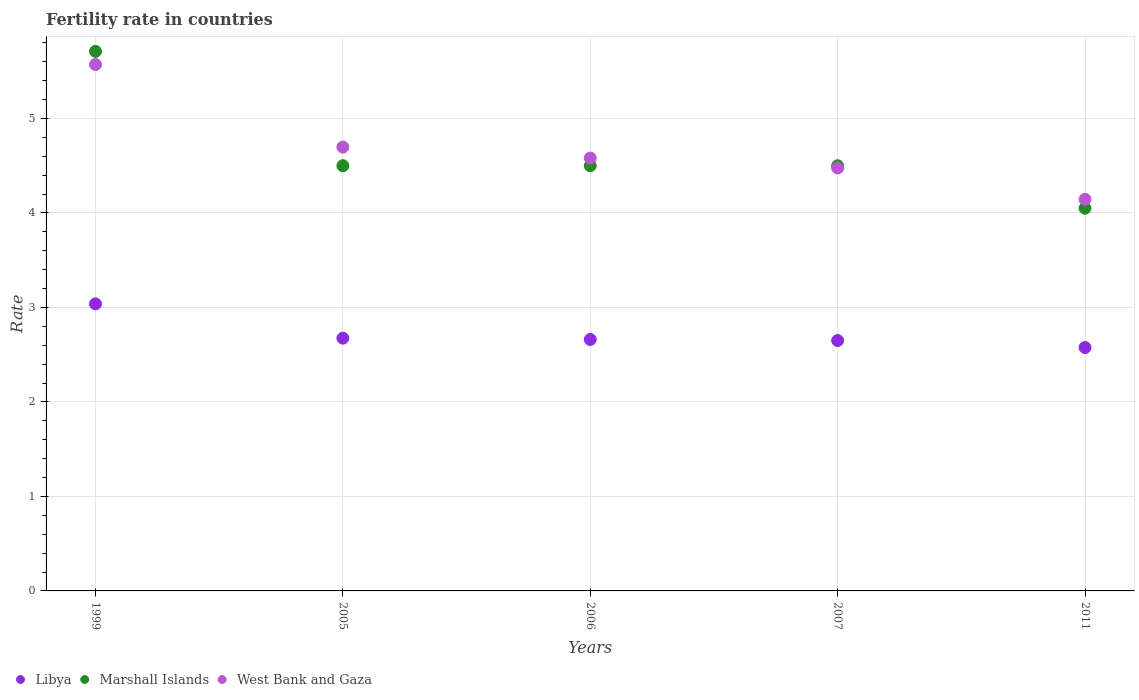Across all years, what is the maximum fertility rate in Libya?
Offer a very short reply. 3.04. Across all years, what is the minimum fertility rate in Marshall Islands?
Provide a succinct answer. 4.05. In which year was the fertility rate in Marshall Islands maximum?
Provide a short and direct response. 1999. In which year was the fertility rate in Marshall Islands minimum?
Provide a short and direct response. 2011. What is the total fertility rate in West Bank and Gaza in the graph?
Make the answer very short. 23.47. What is the difference between the fertility rate in Libya in 1999 and that in 2005?
Give a very brief answer. 0.36. What is the average fertility rate in Marshall Islands per year?
Provide a succinct answer. 4.65. In the year 2007, what is the difference between the fertility rate in Marshall Islands and fertility rate in Libya?
Your answer should be compact. 1.85. What is the ratio of the fertility rate in West Bank and Gaza in 1999 to that in 2005?
Offer a terse response. 1.19. Is the fertility rate in West Bank and Gaza in 1999 less than that in 2007?
Ensure brevity in your answer.  No. Is the difference between the fertility rate in Marshall Islands in 2005 and 2006 greater than the difference between the fertility rate in Libya in 2005 and 2006?
Keep it short and to the point. No. What is the difference between the highest and the second highest fertility rate in West Bank and Gaza?
Give a very brief answer. 0.87. What is the difference between the highest and the lowest fertility rate in West Bank and Gaza?
Your response must be concise. 1.43. Is the sum of the fertility rate in West Bank and Gaza in 1999 and 2006 greater than the maximum fertility rate in Marshall Islands across all years?
Your response must be concise. Yes. Is the fertility rate in Libya strictly less than the fertility rate in West Bank and Gaza over the years?
Your answer should be compact. Yes. How many dotlines are there?
Provide a succinct answer. 3. How many years are there in the graph?
Give a very brief answer. 5. What is the difference between two consecutive major ticks on the Y-axis?
Keep it short and to the point. 1. Does the graph contain any zero values?
Your response must be concise. No. How many legend labels are there?
Ensure brevity in your answer.  3. What is the title of the graph?
Make the answer very short. Fertility rate in countries. What is the label or title of the Y-axis?
Offer a terse response. Rate. What is the Rate in Libya in 1999?
Your answer should be very brief. 3.04. What is the Rate of Marshall Islands in 1999?
Your response must be concise. 5.71. What is the Rate in West Bank and Gaza in 1999?
Ensure brevity in your answer.  5.57. What is the Rate of Libya in 2005?
Ensure brevity in your answer.  2.67. What is the Rate in West Bank and Gaza in 2005?
Keep it short and to the point. 4.7. What is the Rate in Libya in 2006?
Ensure brevity in your answer.  2.66. What is the Rate in Marshall Islands in 2006?
Provide a succinct answer. 4.5. What is the Rate of West Bank and Gaza in 2006?
Keep it short and to the point. 4.58. What is the Rate in Libya in 2007?
Give a very brief answer. 2.65. What is the Rate in West Bank and Gaza in 2007?
Give a very brief answer. 4.48. What is the Rate in Libya in 2011?
Give a very brief answer. 2.58. What is the Rate in Marshall Islands in 2011?
Your answer should be very brief. 4.05. What is the Rate in West Bank and Gaza in 2011?
Give a very brief answer. 4.14. Across all years, what is the maximum Rate of Libya?
Provide a succinct answer. 3.04. Across all years, what is the maximum Rate of Marshall Islands?
Your response must be concise. 5.71. Across all years, what is the maximum Rate of West Bank and Gaza?
Your answer should be compact. 5.57. Across all years, what is the minimum Rate in Libya?
Your answer should be very brief. 2.58. Across all years, what is the minimum Rate of Marshall Islands?
Your answer should be compact. 4.05. Across all years, what is the minimum Rate of West Bank and Gaza?
Give a very brief answer. 4.14. What is the total Rate of Libya in the graph?
Offer a terse response. 13.6. What is the total Rate of Marshall Islands in the graph?
Your answer should be very brief. 23.26. What is the total Rate in West Bank and Gaza in the graph?
Offer a very short reply. 23.47. What is the difference between the Rate in Libya in 1999 and that in 2005?
Ensure brevity in your answer.  0.36. What is the difference between the Rate of Marshall Islands in 1999 and that in 2005?
Offer a very short reply. 1.21. What is the difference between the Rate in West Bank and Gaza in 1999 and that in 2005?
Make the answer very short. 0.87. What is the difference between the Rate in Libya in 1999 and that in 2006?
Make the answer very short. 0.38. What is the difference between the Rate in Marshall Islands in 1999 and that in 2006?
Your answer should be very brief. 1.21. What is the difference between the Rate of West Bank and Gaza in 1999 and that in 2006?
Offer a very short reply. 0.99. What is the difference between the Rate in Libya in 1999 and that in 2007?
Give a very brief answer. 0.39. What is the difference between the Rate in Marshall Islands in 1999 and that in 2007?
Make the answer very short. 1.21. What is the difference between the Rate of West Bank and Gaza in 1999 and that in 2007?
Your response must be concise. 1.09. What is the difference between the Rate of Libya in 1999 and that in 2011?
Your answer should be compact. 0.46. What is the difference between the Rate in Marshall Islands in 1999 and that in 2011?
Your response must be concise. 1.66. What is the difference between the Rate in West Bank and Gaza in 1999 and that in 2011?
Your answer should be compact. 1.43. What is the difference between the Rate of Libya in 2005 and that in 2006?
Give a very brief answer. 0.01. What is the difference between the Rate in Marshall Islands in 2005 and that in 2006?
Your answer should be very brief. 0. What is the difference between the Rate of West Bank and Gaza in 2005 and that in 2006?
Make the answer very short. 0.12. What is the difference between the Rate of Libya in 2005 and that in 2007?
Keep it short and to the point. 0.03. What is the difference between the Rate in Marshall Islands in 2005 and that in 2007?
Your answer should be very brief. 0. What is the difference between the Rate of West Bank and Gaza in 2005 and that in 2007?
Give a very brief answer. 0.22. What is the difference between the Rate in Libya in 2005 and that in 2011?
Offer a very short reply. 0.1. What is the difference between the Rate in Marshall Islands in 2005 and that in 2011?
Keep it short and to the point. 0.45. What is the difference between the Rate of West Bank and Gaza in 2005 and that in 2011?
Make the answer very short. 0.55. What is the difference between the Rate of Libya in 2006 and that in 2007?
Your response must be concise. 0.01. What is the difference between the Rate in West Bank and Gaza in 2006 and that in 2007?
Offer a very short reply. 0.1. What is the difference between the Rate in Libya in 2006 and that in 2011?
Your answer should be very brief. 0.09. What is the difference between the Rate in Marshall Islands in 2006 and that in 2011?
Provide a succinct answer. 0.45. What is the difference between the Rate in West Bank and Gaza in 2006 and that in 2011?
Ensure brevity in your answer.  0.44. What is the difference between the Rate of Libya in 2007 and that in 2011?
Provide a succinct answer. 0.07. What is the difference between the Rate of Marshall Islands in 2007 and that in 2011?
Provide a short and direct response. 0.45. What is the difference between the Rate of West Bank and Gaza in 2007 and that in 2011?
Your answer should be compact. 0.33. What is the difference between the Rate in Libya in 1999 and the Rate in Marshall Islands in 2005?
Provide a short and direct response. -1.46. What is the difference between the Rate in Libya in 1999 and the Rate in West Bank and Gaza in 2005?
Ensure brevity in your answer.  -1.66. What is the difference between the Rate in Libya in 1999 and the Rate in Marshall Islands in 2006?
Ensure brevity in your answer.  -1.46. What is the difference between the Rate of Libya in 1999 and the Rate of West Bank and Gaza in 2006?
Provide a succinct answer. -1.54. What is the difference between the Rate of Marshall Islands in 1999 and the Rate of West Bank and Gaza in 2006?
Make the answer very short. 1.13. What is the difference between the Rate of Libya in 1999 and the Rate of Marshall Islands in 2007?
Keep it short and to the point. -1.46. What is the difference between the Rate in Libya in 1999 and the Rate in West Bank and Gaza in 2007?
Make the answer very short. -1.44. What is the difference between the Rate in Marshall Islands in 1999 and the Rate in West Bank and Gaza in 2007?
Provide a succinct answer. 1.23. What is the difference between the Rate in Libya in 1999 and the Rate in Marshall Islands in 2011?
Provide a short and direct response. -1.01. What is the difference between the Rate of Libya in 1999 and the Rate of West Bank and Gaza in 2011?
Your answer should be compact. -1.11. What is the difference between the Rate in Marshall Islands in 1999 and the Rate in West Bank and Gaza in 2011?
Your answer should be very brief. 1.57. What is the difference between the Rate in Libya in 2005 and the Rate in Marshall Islands in 2006?
Offer a very short reply. -1.82. What is the difference between the Rate in Libya in 2005 and the Rate in West Bank and Gaza in 2006?
Make the answer very short. -1.91. What is the difference between the Rate in Marshall Islands in 2005 and the Rate in West Bank and Gaza in 2006?
Your answer should be compact. -0.08. What is the difference between the Rate of Libya in 2005 and the Rate of Marshall Islands in 2007?
Offer a terse response. -1.82. What is the difference between the Rate in Libya in 2005 and the Rate in West Bank and Gaza in 2007?
Give a very brief answer. -1.8. What is the difference between the Rate in Marshall Islands in 2005 and the Rate in West Bank and Gaza in 2007?
Keep it short and to the point. 0.02. What is the difference between the Rate of Libya in 2005 and the Rate of Marshall Islands in 2011?
Your response must be concise. -1.38. What is the difference between the Rate of Libya in 2005 and the Rate of West Bank and Gaza in 2011?
Your response must be concise. -1.47. What is the difference between the Rate in Marshall Islands in 2005 and the Rate in West Bank and Gaza in 2011?
Keep it short and to the point. 0.36. What is the difference between the Rate in Libya in 2006 and the Rate in Marshall Islands in 2007?
Provide a short and direct response. -1.84. What is the difference between the Rate of Libya in 2006 and the Rate of West Bank and Gaza in 2007?
Offer a very short reply. -1.81. What is the difference between the Rate of Marshall Islands in 2006 and the Rate of West Bank and Gaza in 2007?
Give a very brief answer. 0.02. What is the difference between the Rate of Libya in 2006 and the Rate of Marshall Islands in 2011?
Your answer should be very brief. -1.39. What is the difference between the Rate in Libya in 2006 and the Rate in West Bank and Gaza in 2011?
Keep it short and to the point. -1.48. What is the difference between the Rate in Marshall Islands in 2006 and the Rate in West Bank and Gaza in 2011?
Ensure brevity in your answer.  0.36. What is the difference between the Rate in Libya in 2007 and the Rate in West Bank and Gaza in 2011?
Provide a succinct answer. -1.49. What is the difference between the Rate in Marshall Islands in 2007 and the Rate in West Bank and Gaza in 2011?
Offer a very short reply. 0.36. What is the average Rate in Libya per year?
Offer a very short reply. 2.72. What is the average Rate of Marshall Islands per year?
Your answer should be very brief. 4.65. What is the average Rate in West Bank and Gaza per year?
Give a very brief answer. 4.69. In the year 1999, what is the difference between the Rate of Libya and Rate of Marshall Islands?
Make the answer very short. -2.67. In the year 1999, what is the difference between the Rate of Libya and Rate of West Bank and Gaza?
Your answer should be compact. -2.53. In the year 1999, what is the difference between the Rate in Marshall Islands and Rate in West Bank and Gaza?
Your answer should be compact. 0.14. In the year 2005, what is the difference between the Rate in Libya and Rate in Marshall Islands?
Provide a succinct answer. -1.82. In the year 2005, what is the difference between the Rate in Libya and Rate in West Bank and Gaza?
Make the answer very short. -2.02. In the year 2005, what is the difference between the Rate in Marshall Islands and Rate in West Bank and Gaza?
Offer a very short reply. -0.2. In the year 2006, what is the difference between the Rate of Libya and Rate of Marshall Islands?
Your answer should be very brief. -1.84. In the year 2006, what is the difference between the Rate of Libya and Rate of West Bank and Gaza?
Ensure brevity in your answer.  -1.92. In the year 2006, what is the difference between the Rate in Marshall Islands and Rate in West Bank and Gaza?
Provide a short and direct response. -0.08. In the year 2007, what is the difference between the Rate of Libya and Rate of Marshall Islands?
Ensure brevity in your answer.  -1.85. In the year 2007, what is the difference between the Rate in Libya and Rate in West Bank and Gaza?
Make the answer very short. -1.83. In the year 2007, what is the difference between the Rate in Marshall Islands and Rate in West Bank and Gaza?
Offer a terse response. 0.02. In the year 2011, what is the difference between the Rate of Libya and Rate of Marshall Islands?
Your response must be concise. -1.47. In the year 2011, what is the difference between the Rate in Libya and Rate in West Bank and Gaza?
Keep it short and to the point. -1.57. In the year 2011, what is the difference between the Rate of Marshall Islands and Rate of West Bank and Gaza?
Make the answer very short. -0.09. What is the ratio of the Rate in Libya in 1999 to that in 2005?
Provide a short and direct response. 1.14. What is the ratio of the Rate of Marshall Islands in 1999 to that in 2005?
Make the answer very short. 1.27. What is the ratio of the Rate of West Bank and Gaza in 1999 to that in 2005?
Give a very brief answer. 1.19. What is the ratio of the Rate in Libya in 1999 to that in 2006?
Ensure brevity in your answer.  1.14. What is the ratio of the Rate of Marshall Islands in 1999 to that in 2006?
Your answer should be compact. 1.27. What is the ratio of the Rate in West Bank and Gaza in 1999 to that in 2006?
Make the answer very short. 1.22. What is the ratio of the Rate in Libya in 1999 to that in 2007?
Keep it short and to the point. 1.15. What is the ratio of the Rate of Marshall Islands in 1999 to that in 2007?
Ensure brevity in your answer.  1.27. What is the ratio of the Rate in West Bank and Gaza in 1999 to that in 2007?
Keep it short and to the point. 1.24. What is the ratio of the Rate of Libya in 1999 to that in 2011?
Make the answer very short. 1.18. What is the ratio of the Rate in Marshall Islands in 1999 to that in 2011?
Keep it short and to the point. 1.41. What is the ratio of the Rate in West Bank and Gaza in 1999 to that in 2011?
Provide a short and direct response. 1.34. What is the ratio of the Rate of Libya in 2005 to that in 2006?
Ensure brevity in your answer.  1.01. What is the ratio of the Rate in Marshall Islands in 2005 to that in 2006?
Your response must be concise. 1. What is the ratio of the Rate of West Bank and Gaza in 2005 to that in 2006?
Make the answer very short. 1.03. What is the ratio of the Rate in Libya in 2005 to that in 2007?
Provide a short and direct response. 1.01. What is the ratio of the Rate of Marshall Islands in 2005 to that in 2007?
Provide a short and direct response. 1. What is the ratio of the Rate of West Bank and Gaza in 2005 to that in 2007?
Your response must be concise. 1.05. What is the ratio of the Rate of Libya in 2005 to that in 2011?
Ensure brevity in your answer.  1.04. What is the ratio of the Rate of West Bank and Gaza in 2005 to that in 2011?
Make the answer very short. 1.13. What is the ratio of the Rate of West Bank and Gaza in 2006 to that in 2007?
Provide a succinct answer. 1.02. What is the ratio of the Rate of Libya in 2006 to that in 2011?
Keep it short and to the point. 1.03. What is the ratio of the Rate of Marshall Islands in 2006 to that in 2011?
Offer a very short reply. 1.11. What is the ratio of the Rate of West Bank and Gaza in 2006 to that in 2011?
Make the answer very short. 1.11. What is the ratio of the Rate in Libya in 2007 to that in 2011?
Provide a succinct answer. 1.03. What is the ratio of the Rate of Marshall Islands in 2007 to that in 2011?
Provide a short and direct response. 1.11. What is the ratio of the Rate of West Bank and Gaza in 2007 to that in 2011?
Give a very brief answer. 1.08. What is the difference between the highest and the second highest Rate in Libya?
Your answer should be compact. 0.36. What is the difference between the highest and the second highest Rate in Marshall Islands?
Keep it short and to the point. 1.21. What is the difference between the highest and the second highest Rate in West Bank and Gaza?
Offer a very short reply. 0.87. What is the difference between the highest and the lowest Rate of Libya?
Your answer should be very brief. 0.46. What is the difference between the highest and the lowest Rate of Marshall Islands?
Give a very brief answer. 1.66. What is the difference between the highest and the lowest Rate in West Bank and Gaza?
Give a very brief answer. 1.43. 